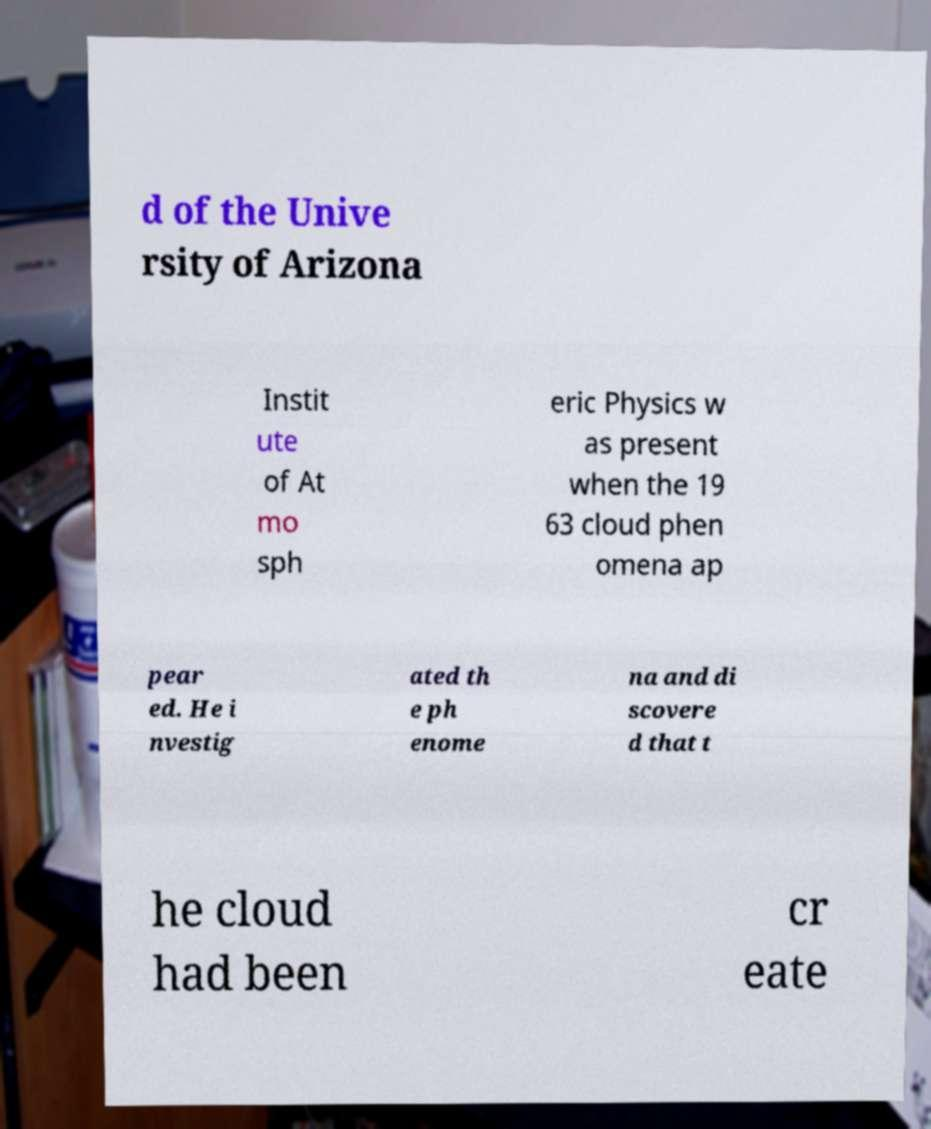Please read and relay the text visible in this image. What does it say? d of the Unive rsity of Arizona Instit ute of At mo sph eric Physics w as present when the 19 63 cloud phen omena ap pear ed. He i nvestig ated th e ph enome na and di scovere d that t he cloud had been cr eate 